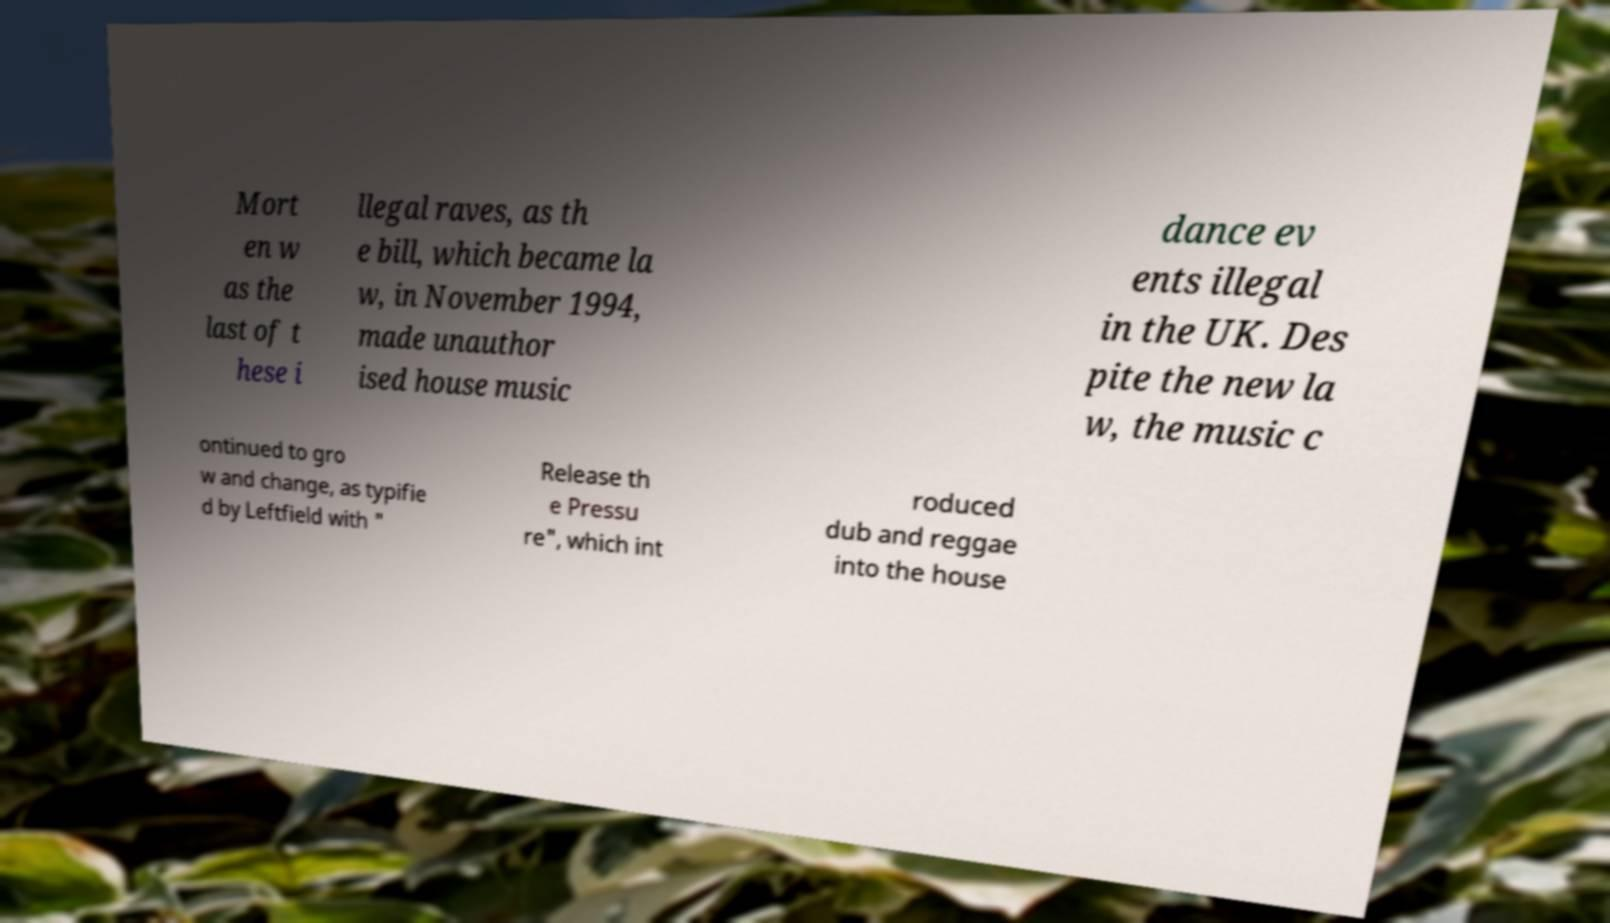For documentation purposes, I need the text within this image transcribed. Could you provide that? Mort en w as the last of t hese i llegal raves, as th e bill, which became la w, in November 1994, made unauthor ised house music dance ev ents illegal in the UK. Des pite the new la w, the music c ontinued to gro w and change, as typifie d by Leftfield with " Release th e Pressu re", which int roduced dub and reggae into the house 